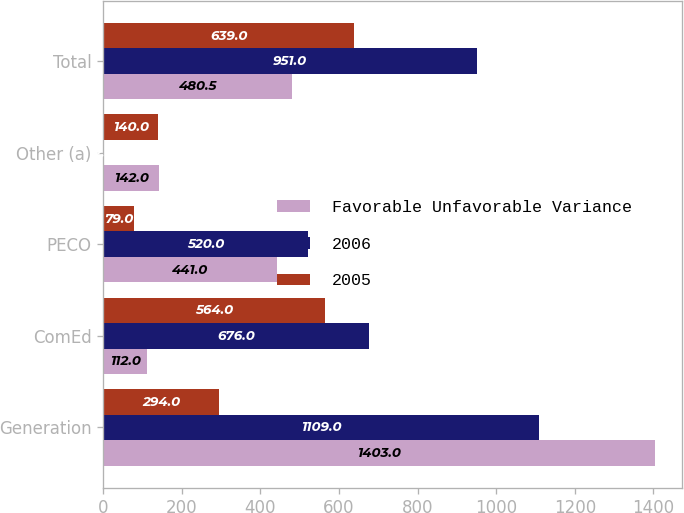Convert chart. <chart><loc_0><loc_0><loc_500><loc_500><stacked_bar_chart><ecel><fcel>Generation<fcel>ComEd<fcel>PECO<fcel>Other (a)<fcel>Total<nl><fcel>Favorable Unfavorable Variance<fcel>1403<fcel>112<fcel>441<fcel>142<fcel>480.5<nl><fcel>2006<fcel>1109<fcel>676<fcel>520<fcel>2<fcel>951<nl><fcel>2005<fcel>294<fcel>564<fcel>79<fcel>140<fcel>639<nl></chart> 